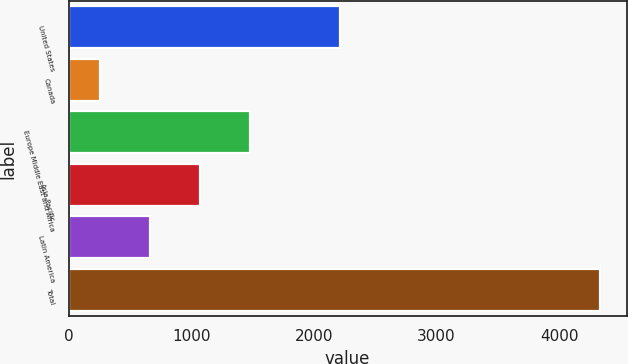<chart> <loc_0><loc_0><loc_500><loc_500><bar_chart><fcel>United States<fcel>Canada<fcel>Europe Middle East and Africa<fcel>Asia-Pacific<fcel>Latin America<fcel>Total<nl><fcel>2209.2<fcel>257.1<fcel>1479.72<fcel>1072.18<fcel>664.64<fcel>4332.5<nl></chart> 